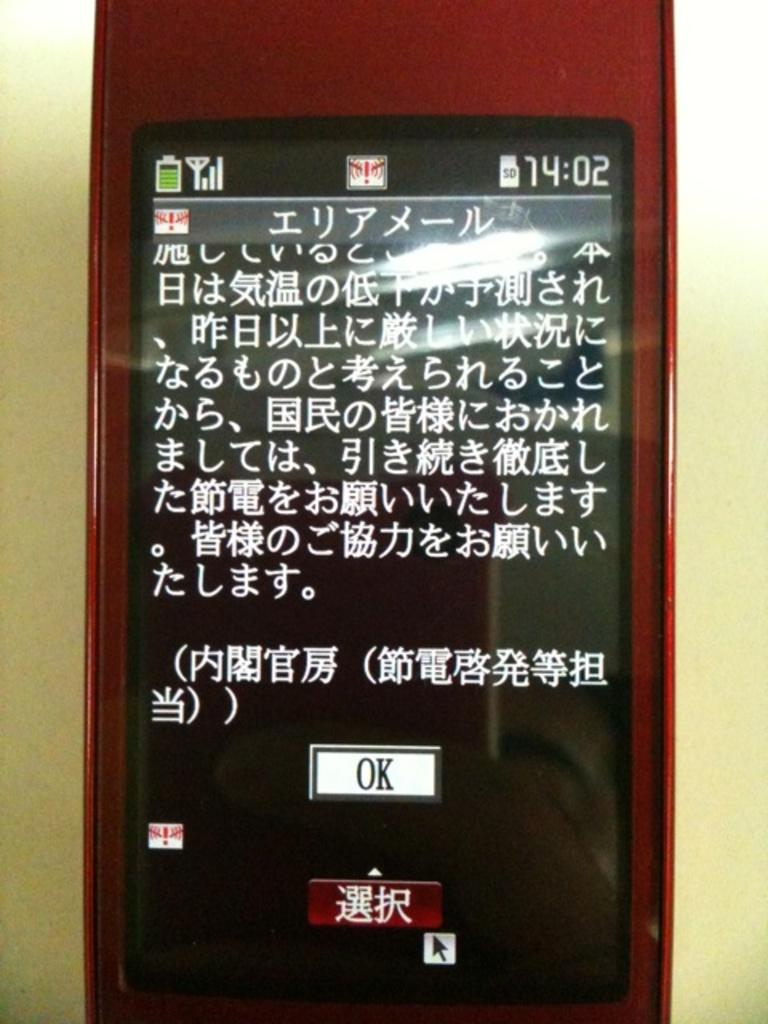<image>
Relay a brief, clear account of the picture shown. A red cell phone with Japanese writing on the screen with an OK button displayed near the bottom. 